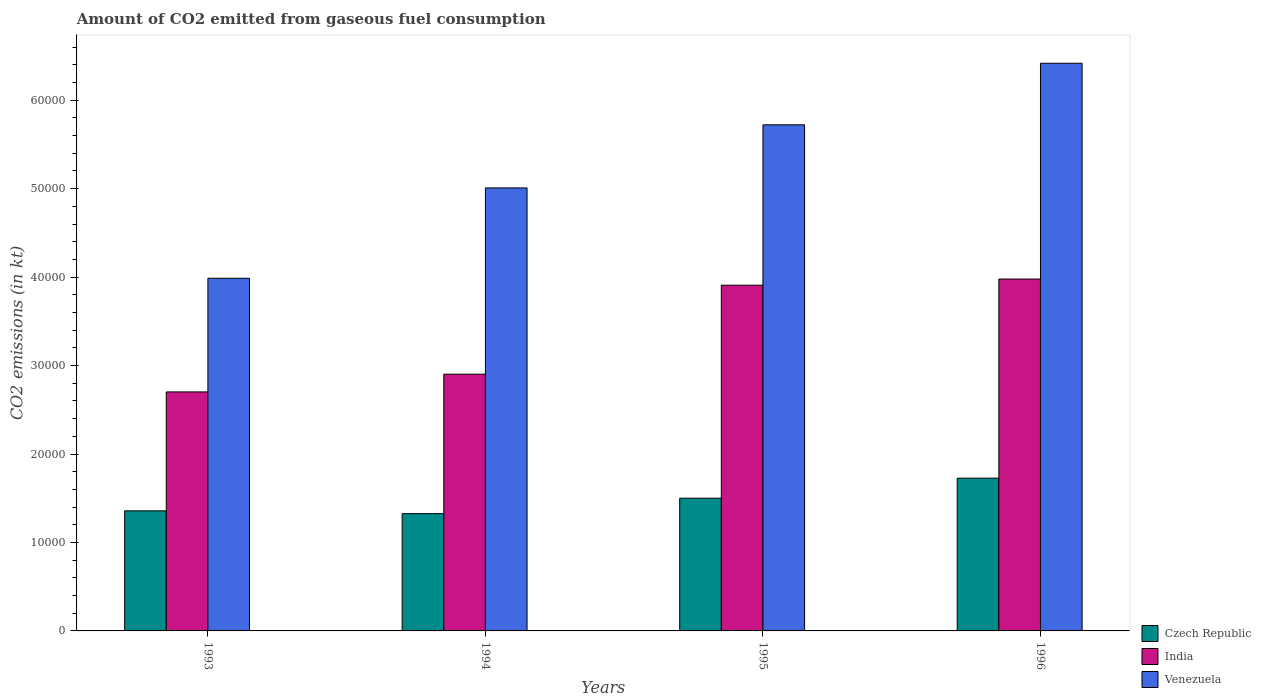How many different coloured bars are there?
Make the answer very short. 3. How many groups of bars are there?
Ensure brevity in your answer.  4. Are the number of bars per tick equal to the number of legend labels?
Make the answer very short. Yes. How many bars are there on the 2nd tick from the right?
Your answer should be compact. 3. What is the label of the 1st group of bars from the left?
Make the answer very short. 1993. What is the amount of CO2 emitted in India in 1993?
Give a very brief answer. 2.70e+04. Across all years, what is the maximum amount of CO2 emitted in India?
Your answer should be very brief. 3.98e+04. Across all years, what is the minimum amount of CO2 emitted in Czech Republic?
Ensure brevity in your answer.  1.33e+04. What is the total amount of CO2 emitted in Venezuela in the graph?
Offer a very short reply. 2.11e+05. What is the difference between the amount of CO2 emitted in Venezuela in 1993 and that in 1995?
Your answer should be very brief. -1.73e+04. What is the difference between the amount of CO2 emitted in Czech Republic in 1993 and the amount of CO2 emitted in Venezuela in 1996?
Provide a succinct answer. -5.06e+04. What is the average amount of CO2 emitted in Venezuela per year?
Give a very brief answer. 5.28e+04. In the year 1996, what is the difference between the amount of CO2 emitted in India and amount of CO2 emitted in Czech Republic?
Make the answer very short. 2.25e+04. In how many years, is the amount of CO2 emitted in Czech Republic greater than 42000 kt?
Keep it short and to the point. 0. What is the ratio of the amount of CO2 emitted in Venezuela in 1993 to that in 1994?
Provide a short and direct response. 0.8. Is the amount of CO2 emitted in Venezuela in 1994 less than that in 1995?
Keep it short and to the point. Yes. What is the difference between the highest and the second highest amount of CO2 emitted in India?
Give a very brief answer. 696.73. What is the difference between the highest and the lowest amount of CO2 emitted in India?
Keep it short and to the point. 1.28e+04. What does the 3rd bar from the left in 1995 represents?
Ensure brevity in your answer.  Venezuela. What does the 2nd bar from the right in 1994 represents?
Offer a terse response. India. Is it the case that in every year, the sum of the amount of CO2 emitted in India and amount of CO2 emitted in Venezuela is greater than the amount of CO2 emitted in Czech Republic?
Give a very brief answer. Yes. What is the difference between two consecutive major ticks on the Y-axis?
Provide a succinct answer. 10000. Does the graph contain grids?
Offer a terse response. No. How many legend labels are there?
Your answer should be compact. 3. What is the title of the graph?
Your answer should be very brief. Amount of CO2 emitted from gaseous fuel consumption. What is the label or title of the Y-axis?
Give a very brief answer. CO2 emissions (in kt). What is the CO2 emissions (in kt) in Czech Republic in 1993?
Offer a terse response. 1.36e+04. What is the CO2 emissions (in kt) of India in 1993?
Make the answer very short. 2.70e+04. What is the CO2 emissions (in kt) of Venezuela in 1993?
Provide a succinct answer. 3.99e+04. What is the CO2 emissions (in kt) in Czech Republic in 1994?
Make the answer very short. 1.33e+04. What is the CO2 emissions (in kt) of India in 1994?
Your answer should be very brief. 2.90e+04. What is the CO2 emissions (in kt) of Venezuela in 1994?
Offer a terse response. 5.01e+04. What is the CO2 emissions (in kt) in Czech Republic in 1995?
Your answer should be very brief. 1.50e+04. What is the CO2 emissions (in kt) of India in 1995?
Keep it short and to the point. 3.91e+04. What is the CO2 emissions (in kt) in Venezuela in 1995?
Provide a short and direct response. 5.72e+04. What is the CO2 emissions (in kt) in Czech Republic in 1996?
Your answer should be compact. 1.73e+04. What is the CO2 emissions (in kt) in India in 1996?
Make the answer very short. 3.98e+04. What is the CO2 emissions (in kt) of Venezuela in 1996?
Provide a succinct answer. 6.42e+04. Across all years, what is the maximum CO2 emissions (in kt) of Czech Republic?
Make the answer very short. 1.73e+04. Across all years, what is the maximum CO2 emissions (in kt) of India?
Provide a succinct answer. 3.98e+04. Across all years, what is the maximum CO2 emissions (in kt) of Venezuela?
Your response must be concise. 6.42e+04. Across all years, what is the minimum CO2 emissions (in kt) of Czech Republic?
Your answer should be very brief. 1.33e+04. Across all years, what is the minimum CO2 emissions (in kt) of India?
Ensure brevity in your answer.  2.70e+04. Across all years, what is the minimum CO2 emissions (in kt) of Venezuela?
Your response must be concise. 3.99e+04. What is the total CO2 emissions (in kt) of Czech Republic in the graph?
Offer a very short reply. 5.91e+04. What is the total CO2 emissions (in kt) of India in the graph?
Your answer should be very brief. 1.35e+05. What is the total CO2 emissions (in kt) of Venezuela in the graph?
Keep it short and to the point. 2.11e+05. What is the difference between the CO2 emissions (in kt) of Czech Republic in 1993 and that in 1994?
Your answer should be very brief. 315.36. What is the difference between the CO2 emissions (in kt) in India in 1993 and that in 1994?
Provide a succinct answer. -2005.85. What is the difference between the CO2 emissions (in kt) of Venezuela in 1993 and that in 1994?
Ensure brevity in your answer.  -1.02e+04. What is the difference between the CO2 emissions (in kt) of Czech Republic in 1993 and that in 1995?
Keep it short and to the point. -1430.13. What is the difference between the CO2 emissions (in kt) in India in 1993 and that in 1995?
Provide a succinct answer. -1.21e+04. What is the difference between the CO2 emissions (in kt) in Venezuela in 1993 and that in 1995?
Make the answer very short. -1.73e+04. What is the difference between the CO2 emissions (in kt) of Czech Republic in 1993 and that in 1996?
Keep it short and to the point. -3692.67. What is the difference between the CO2 emissions (in kt) in India in 1993 and that in 1996?
Your answer should be compact. -1.28e+04. What is the difference between the CO2 emissions (in kt) in Venezuela in 1993 and that in 1996?
Your answer should be very brief. -2.43e+04. What is the difference between the CO2 emissions (in kt) in Czech Republic in 1994 and that in 1995?
Keep it short and to the point. -1745.49. What is the difference between the CO2 emissions (in kt) in India in 1994 and that in 1995?
Offer a terse response. -1.01e+04. What is the difference between the CO2 emissions (in kt) in Venezuela in 1994 and that in 1995?
Your answer should be very brief. -7132.31. What is the difference between the CO2 emissions (in kt) in Czech Republic in 1994 and that in 1996?
Give a very brief answer. -4008.03. What is the difference between the CO2 emissions (in kt) of India in 1994 and that in 1996?
Make the answer very short. -1.08e+04. What is the difference between the CO2 emissions (in kt) in Venezuela in 1994 and that in 1996?
Provide a succinct answer. -1.41e+04. What is the difference between the CO2 emissions (in kt) in Czech Republic in 1995 and that in 1996?
Your answer should be compact. -2262.54. What is the difference between the CO2 emissions (in kt) of India in 1995 and that in 1996?
Your answer should be very brief. -696.73. What is the difference between the CO2 emissions (in kt) in Venezuela in 1995 and that in 1996?
Your answer should be compact. -6959.97. What is the difference between the CO2 emissions (in kt) in Czech Republic in 1993 and the CO2 emissions (in kt) in India in 1994?
Provide a short and direct response. -1.54e+04. What is the difference between the CO2 emissions (in kt) of Czech Republic in 1993 and the CO2 emissions (in kt) of Venezuela in 1994?
Your answer should be very brief. -3.65e+04. What is the difference between the CO2 emissions (in kt) in India in 1993 and the CO2 emissions (in kt) in Venezuela in 1994?
Provide a succinct answer. -2.31e+04. What is the difference between the CO2 emissions (in kt) of Czech Republic in 1993 and the CO2 emissions (in kt) of India in 1995?
Your answer should be compact. -2.55e+04. What is the difference between the CO2 emissions (in kt) in Czech Republic in 1993 and the CO2 emissions (in kt) in Venezuela in 1995?
Give a very brief answer. -4.36e+04. What is the difference between the CO2 emissions (in kt) in India in 1993 and the CO2 emissions (in kt) in Venezuela in 1995?
Ensure brevity in your answer.  -3.02e+04. What is the difference between the CO2 emissions (in kt) in Czech Republic in 1993 and the CO2 emissions (in kt) in India in 1996?
Your answer should be very brief. -2.62e+04. What is the difference between the CO2 emissions (in kt) of Czech Republic in 1993 and the CO2 emissions (in kt) of Venezuela in 1996?
Offer a very short reply. -5.06e+04. What is the difference between the CO2 emissions (in kt) of India in 1993 and the CO2 emissions (in kt) of Venezuela in 1996?
Your answer should be very brief. -3.72e+04. What is the difference between the CO2 emissions (in kt) of Czech Republic in 1994 and the CO2 emissions (in kt) of India in 1995?
Keep it short and to the point. -2.58e+04. What is the difference between the CO2 emissions (in kt) in Czech Republic in 1994 and the CO2 emissions (in kt) in Venezuela in 1995?
Offer a very short reply. -4.40e+04. What is the difference between the CO2 emissions (in kt) of India in 1994 and the CO2 emissions (in kt) of Venezuela in 1995?
Your answer should be compact. -2.82e+04. What is the difference between the CO2 emissions (in kt) in Czech Republic in 1994 and the CO2 emissions (in kt) in India in 1996?
Your answer should be very brief. -2.65e+04. What is the difference between the CO2 emissions (in kt) of Czech Republic in 1994 and the CO2 emissions (in kt) of Venezuela in 1996?
Keep it short and to the point. -5.09e+04. What is the difference between the CO2 emissions (in kt) of India in 1994 and the CO2 emissions (in kt) of Venezuela in 1996?
Ensure brevity in your answer.  -3.51e+04. What is the difference between the CO2 emissions (in kt) in Czech Republic in 1995 and the CO2 emissions (in kt) in India in 1996?
Make the answer very short. -2.48e+04. What is the difference between the CO2 emissions (in kt) of Czech Republic in 1995 and the CO2 emissions (in kt) of Venezuela in 1996?
Offer a terse response. -4.92e+04. What is the difference between the CO2 emissions (in kt) in India in 1995 and the CO2 emissions (in kt) in Venezuela in 1996?
Your answer should be compact. -2.51e+04. What is the average CO2 emissions (in kt) of Czech Republic per year?
Make the answer very short. 1.48e+04. What is the average CO2 emissions (in kt) of India per year?
Your answer should be compact. 3.37e+04. What is the average CO2 emissions (in kt) in Venezuela per year?
Keep it short and to the point. 5.28e+04. In the year 1993, what is the difference between the CO2 emissions (in kt) in Czech Republic and CO2 emissions (in kt) in India?
Ensure brevity in your answer.  -1.34e+04. In the year 1993, what is the difference between the CO2 emissions (in kt) of Czech Republic and CO2 emissions (in kt) of Venezuela?
Make the answer very short. -2.63e+04. In the year 1993, what is the difference between the CO2 emissions (in kt) in India and CO2 emissions (in kt) in Venezuela?
Ensure brevity in your answer.  -1.28e+04. In the year 1994, what is the difference between the CO2 emissions (in kt) of Czech Republic and CO2 emissions (in kt) of India?
Make the answer very short. -1.58e+04. In the year 1994, what is the difference between the CO2 emissions (in kt) in Czech Republic and CO2 emissions (in kt) in Venezuela?
Offer a terse response. -3.68e+04. In the year 1994, what is the difference between the CO2 emissions (in kt) of India and CO2 emissions (in kt) of Venezuela?
Your response must be concise. -2.11e+04. In the year 1995, what is the difference between the CO2 emissions (in kt) of Czech Republic and CO2 emissions (in kt) of India?
Your answer should be compact. -2.41e+04. In the year 1995, what is the difference between the CO2 emissions (in kt) of Czech Republic and CO2 emissions (in kt) of Venezuela?
Your answer should be compact. -4.22e+04. In the year 1995, what is the difference between the CO2 emissions (in kt) in India and CO2 emissions (in kt) in Venezuela?
Your answer should be compact. -1.81e+04. In the year 1996, what is the difference between the CO2 emissions (in kt) of Czech Republic and CO2 emissions (in kt) of India?
Your answer should be very brief. -2.25e+04. In the year 1996, what is the difference between the CO2 emissions (in kt) in Czech Republic and CO2 emissions (in kt) in Venezuela?
Keep it short and to the point. -4.69e+04. In the year 1996, what is the difference between the CO2 emissions (in kt) of India and CO2 emissions (in kt) of Venezuela?
Offer a terse response. -2.44e+04. What is the ratio of the CO2 emissions (in kt) in Czech Republic in 1993 to that in 1994?
Ensure brevity in your answer.  1.02. What is the ratio of the CO2 emissions (in kt) in India in 1993 to that in 1994?
Your answer should be compact. 0.93. What is the ratio of the CO2 emissions (in kt) in Venezuela in 1993 to that in 1994?
Give a very brief answer. 0.8. What is the ratio of the CO2 emissions (in kt) of Czech Republic in 1993 to that in 1995?
Ensure brevity in your answer.  0.9. What is the ratio of the CO2 emissions (in kt) in India in 1993 to that in 1995?
Offer a terse response. 0.69. What is the ratio of the CO2 emissions (in kt) of Venezuela in 1993 to that in 1995?
Provide a succinct answer. 0.7. What is the ratio of the CO2 emissions (in kt) in Czech Republic in 1993 to that in 1996?
Your response must be concise. 0.79. What is the ratio of the CO2 emissions (in kt) of India in 1993 to that in 1996?
Offer a terse response. 0.68. What is the ratio of the CO2 emissions (in kt) of Venezuela in 1993 to that in 1996?
Give a very brief answer. 0.62. What is the ratio of the CO2 emissions (in kt) in Czech Republic in 1994 to that in 1995?
Provide a short and direct response. 0.88. What is the ratio of the CO2 emissions (in kt) of India in 1994 to that in 1995?
Offer a very short reply. 0.74. What is the ratio of the CO2 emissions (in kt) in Venezuela in 1994 to that in 1995?
Provide a short and direct response. 0.88. What is the ratio of the CO2 emissions (in kt) in Czech Republic in 1994 to that in 1996?
Provide a succinct answer. 0.77. What is the ratio of the CO2 emissions (in kt) in India in 1994 to that in 1996?
Make the answer very short. 0.73. What is the ratio of the CO2 emissions (in kt) of Venezuela in 1994 to that in 1996?
Your response must be concise. 0.78. What is the ratio of the CO2 emissions (in kt) of Czech Republic in 1995 to that in 1996?
Ensure brevity in your answer.  0.87. What is the ratio of the CO2 emissions (in kt) of India in 1995 to that in 1996?
Keep it short and to the point. 0.98. What is the ratio of the CO2 emissions (in kt) of Venezuela in 1995 to that in 1996?
Make the answer very short. 0.89. What is the difference between the highest and the second highest CO2 emissions (in kt) in Czech Republic?
Give a very brief answer. 2262.54. What is the difference between the highest and the second highest CO2 emissions (in kt) of India?
Ensure brevity in your answer.  696.73. What is the difference between the highest and the second highest CO2 emissions (in kt) of Venezuela?
Keep it short and to the point. 6959.97. What is the difference between the highest and the lowest CO2 emissions (in kt) of Czech Republic?
Give a very brief answer. 4008.03. What is the difference between the highest and the lowest CO2 emissions (in kt) in India?
Your response must be concise. 1.28e+04. What is the difference between the highest and the lowest CO2 emissions (in kt) of Venezuela?
Offer a very short reply. 2.43e+04. 